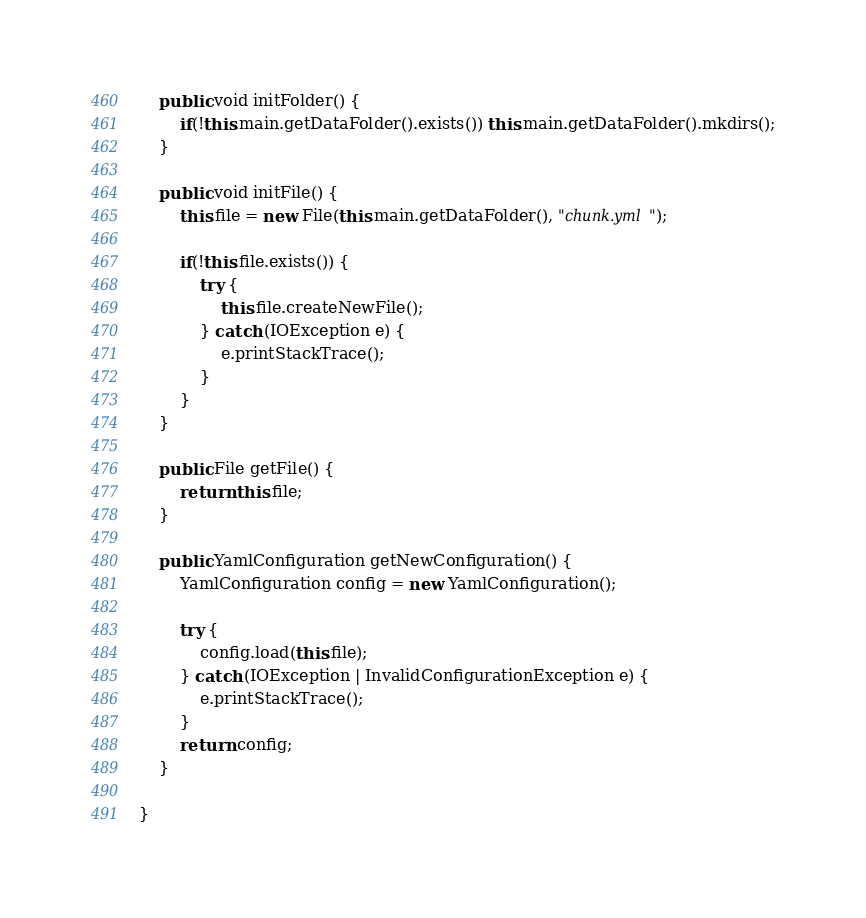<code> <loc_0><loc_0><loc_500><loc_500><_Java_>	public void initFolder() {
		if(!this.main.getDataFolder().exists()) this.main.getDataFolder().mkdirs();
	}
	
	public void initFile() {
		this.file = new File(this.main.getDataFolder(), "chunk.yml");
		
		if(!this.file.exists()) {
			try {
				this.file.createNewFile();
			} catch (IOException e) {
				e.printStackTrace();
			}
		}
	}
	
	public File getFile() {
		return this.file;
	}
	
	public YamlConfiguration getNewConfiguration() {
		YamlConfiguration config = new YamlConfiguration();
		
		try {
			config.load(this.file);
		} catch (IOException | InvalidConfigurationException e) {
			e.printStackTrace();
		} 
		return config;
	}
	
}
</code> 